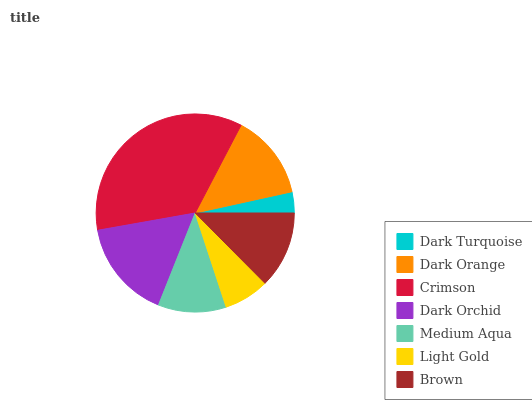Is Dark Turquoise the minimum?
Answer yes or no. Yes. Is Crimson the maximum?
Answer yes or no. Yes. Is Dark Orange the minimum?
Answer yes or no. No. Is Dark Orange the maximum?
Answer yes or no. No. Is Dark Orange greater than Dark Turquoise?
Answer yes or no. Yes. Is Dark Turquoise less than Dark Orange?
Answer yes or no. Yes. Is Dark Turquoise greater than Dark Orange?
Answer yes or no. No. Is Dark Orange less than Dark Turquoise?
Answer yes or no. No. Is Brown the high median?
Answer yes or no. Yes. Is Brown the low median?
Answer yes or no. Yes. Is Medium Aqua the high median?
Answer yes or no. No. Is Dark Orchid the low median?
Answer yes or no. No. 